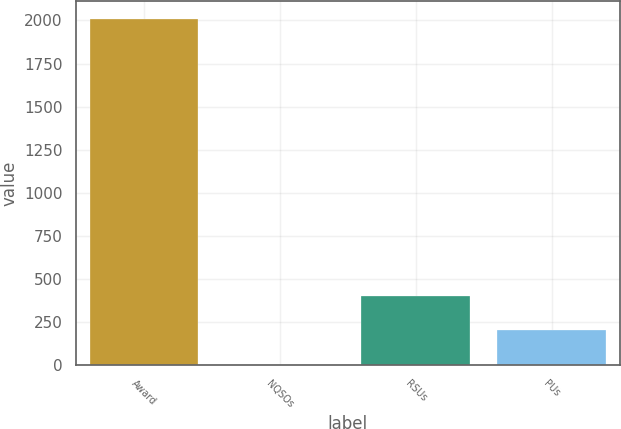<chart> <loc_0><loc_0><loc_500><loc_500><bar_chart><fcel>Award<fcel>NQSOs<fcel>RSUs<fcel>PUs<nl><fcel>2010<fcel>1.2<fcel>402.96<fcel>202.08<nl></chart> 